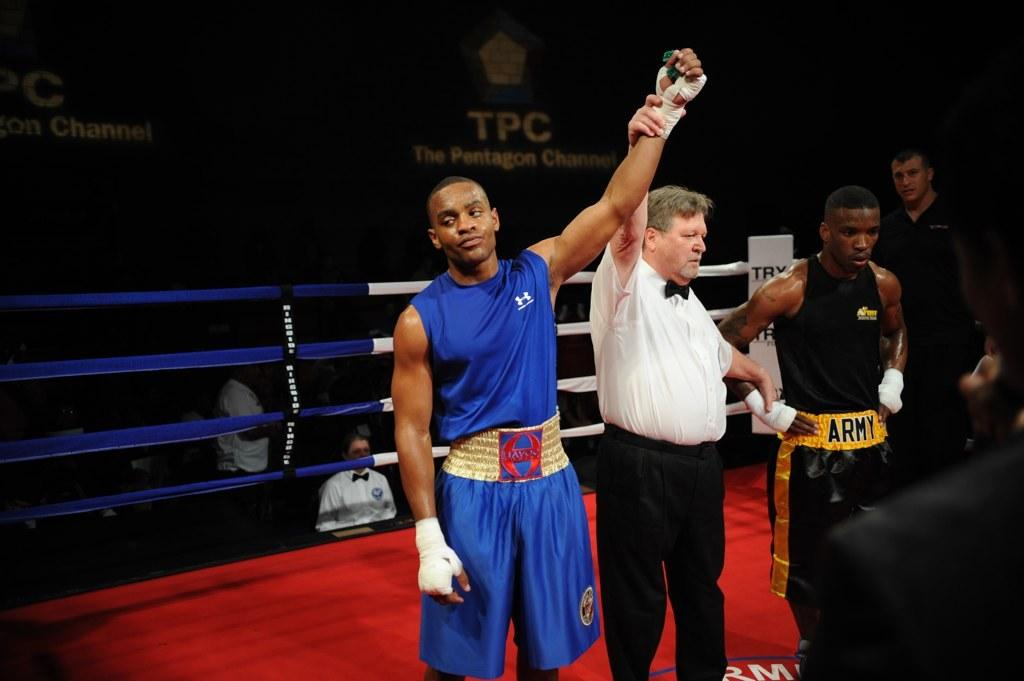<image>
Summarize the visual content of the image. A boxing referee is holding up the winner's hand and the loser has a belt that says Army. 